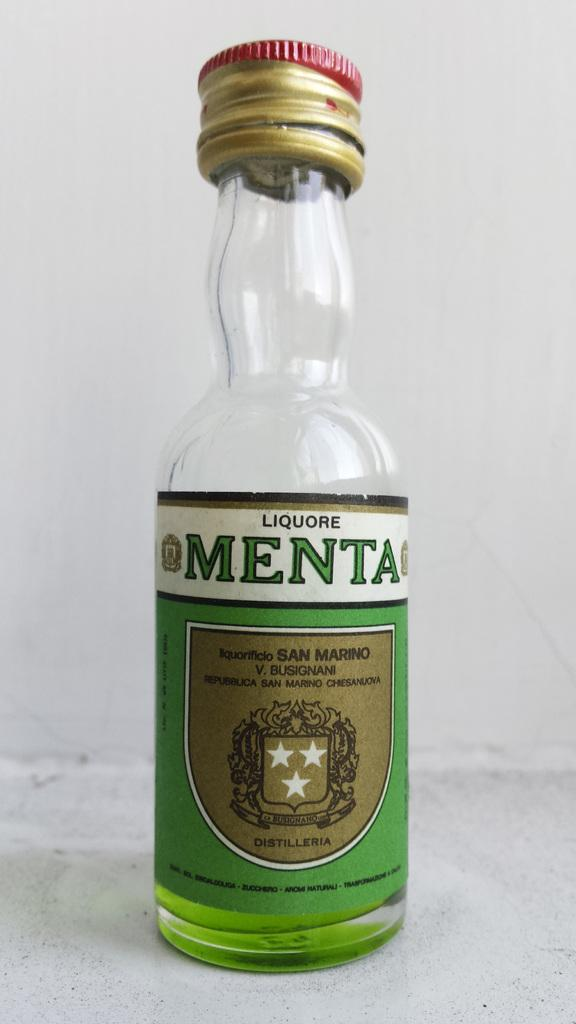What is located in the center of the image? There is a bottle in the center of the image. What is written on the bottle? The bottle has "Meta" written on it. What can be seen in the background of the image? There is a wall in the background of the image. Can you see a toad sitting on top of the bottle in the image? There is no toad present in the image. What type of wine is being served in the bottle in the image? The image does not show any wine or indicate that the bottle contains wine. 